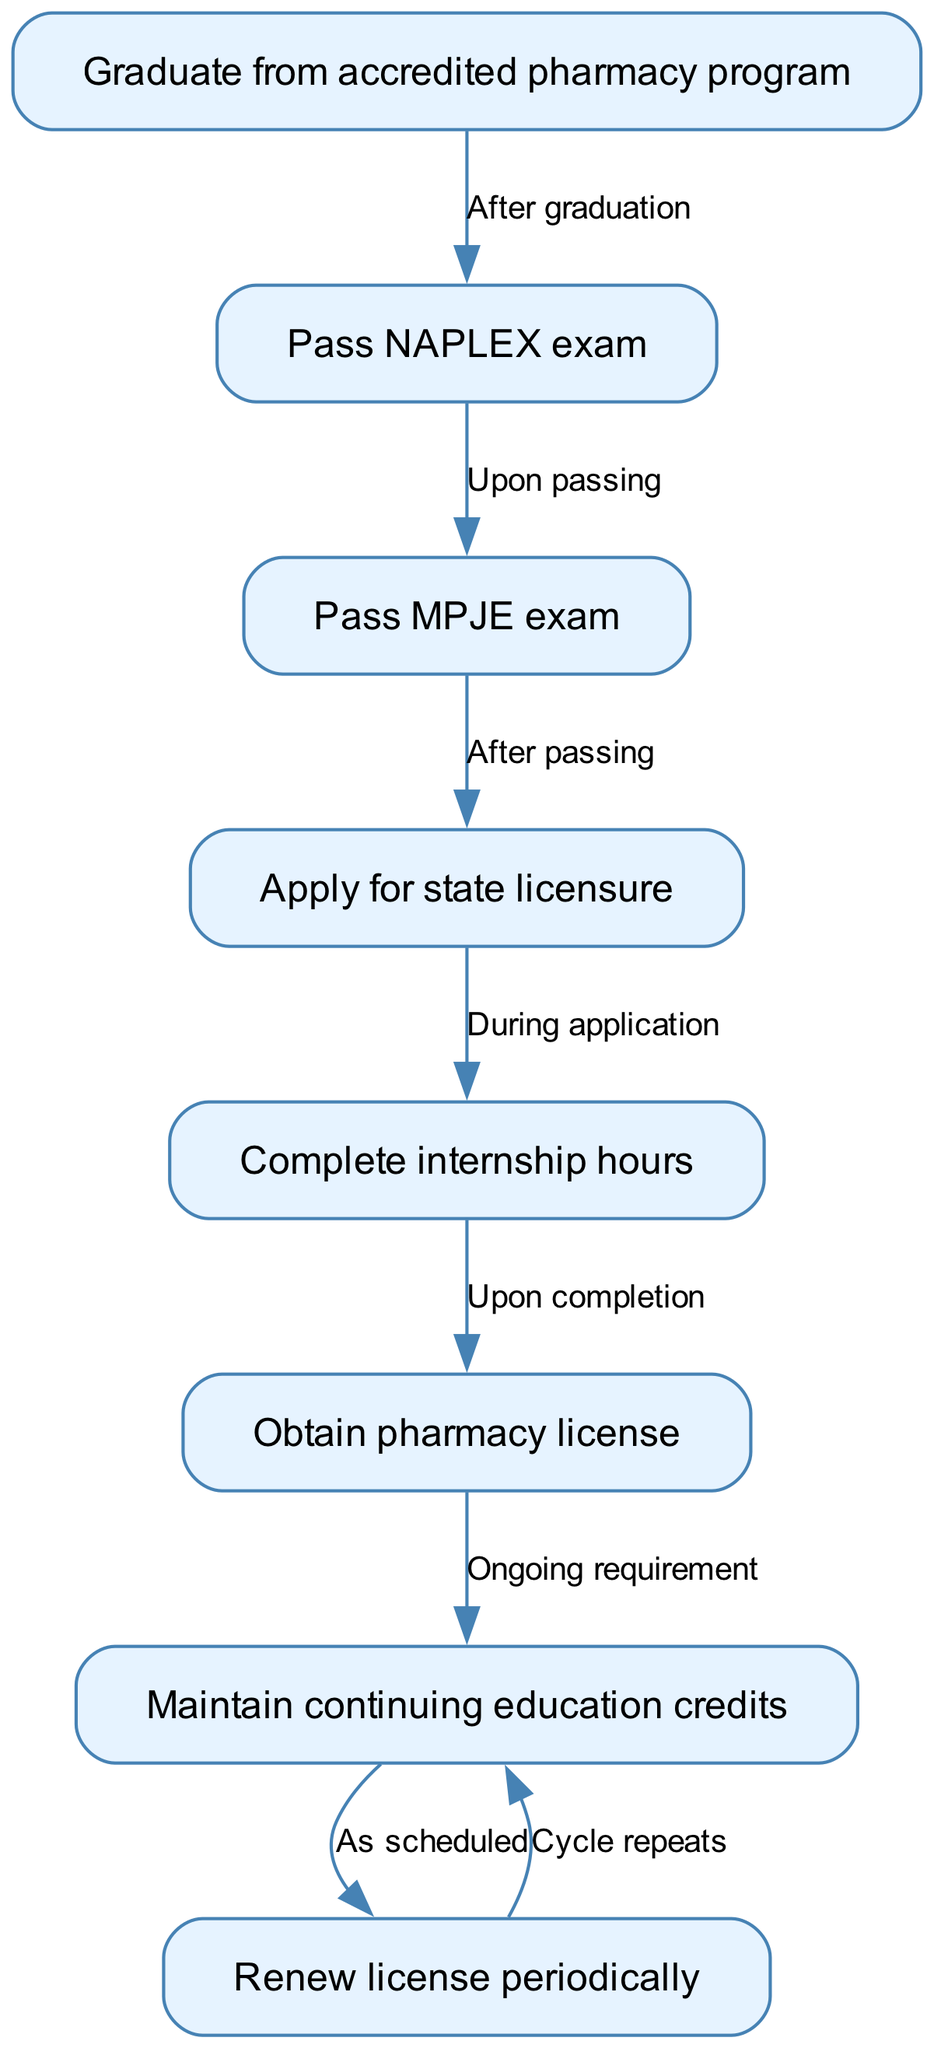What is the first step in obtaining a pharmacy license? The first node in the diagram indicates that one must graduate from an accredited pharmacy program as the initial step.
Answer: Graduate from accredited pharmacy program How many exams must be passed to proceed to applying for state licensure? According to the flow chart, one must pass two exams: the NAPLEX and the MPJE, before applying for state licensure.
Answer: Two What happens after completing internship hours? The diagram shows that completing internship hours leads to obtaining a pharmacy license, which is the next step in the process.
Answer: Obtain pharmacy license What is an ongoing requirement after obtaining a pharmacy license? The flow chart states that maintaining continuing education credits is an ongoing requirement following the acquisition of a pharmacy license.
Answer: Maintain continuing education credits What is the relationship between maintaining continuing education credits and renewing the license? The diagram indicates that after maintaining continuing education credits, the next step is to renew the license periodically, establishing a direct relationship in the process.
Answer: Renew license periodically What is the cycle that occurs after renewing the pharmacy license? After renewing the license periodically, the cycle indicates that one must again maintain continuing education credits, creating a repeating process.
Answer: Cycle repeats What is required during the application for state licensure? The flow chart specifies that completing internship hours is required during the application process for state licensure.
Answer: Complete internship hours How many nodes are in the diagram? By counting the distinct processes listed in the diagram, we find there are eight nodes representing the steps in obtaining and maintaining pharmacy licensure.
Answer: Eight What is the significance of the edge labeled 'Upon passing'? This edge connects the nodes for passing the NAPLEX exam and passing the MPJE exam, indicating these events are sequential and that one occurs after the other.
Answer: Sequential process 